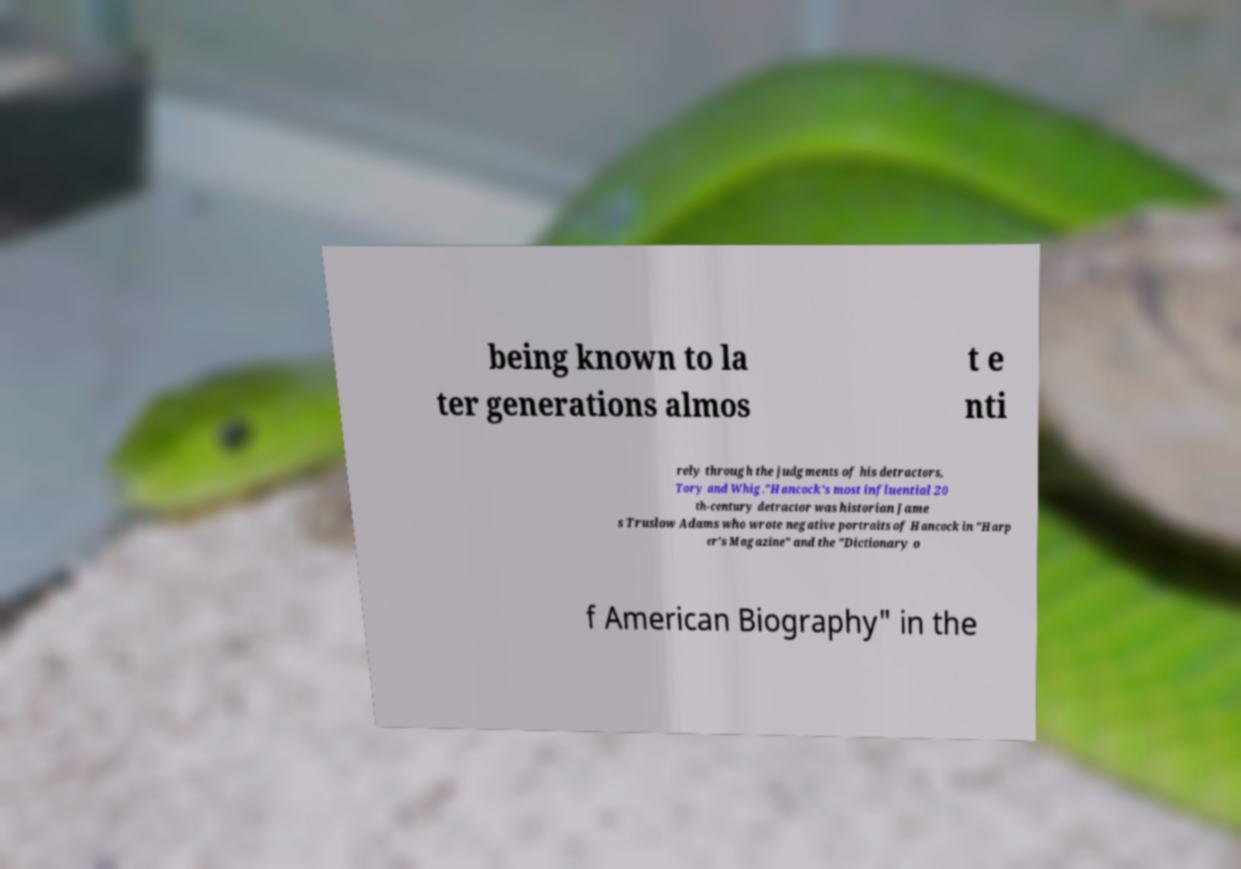Please read and relay the text visible in this image. What does it say? being known to la ter generations almos t e nti rely through the judgments of his detractors, Tory and Whig."Hancock's most influential 20 th-century detractor was historian Jame s Truslow Adams who wrote negative portraits of Hancock in "Harp er's Magazine" and the "Dictionary o f American Biography" in the 